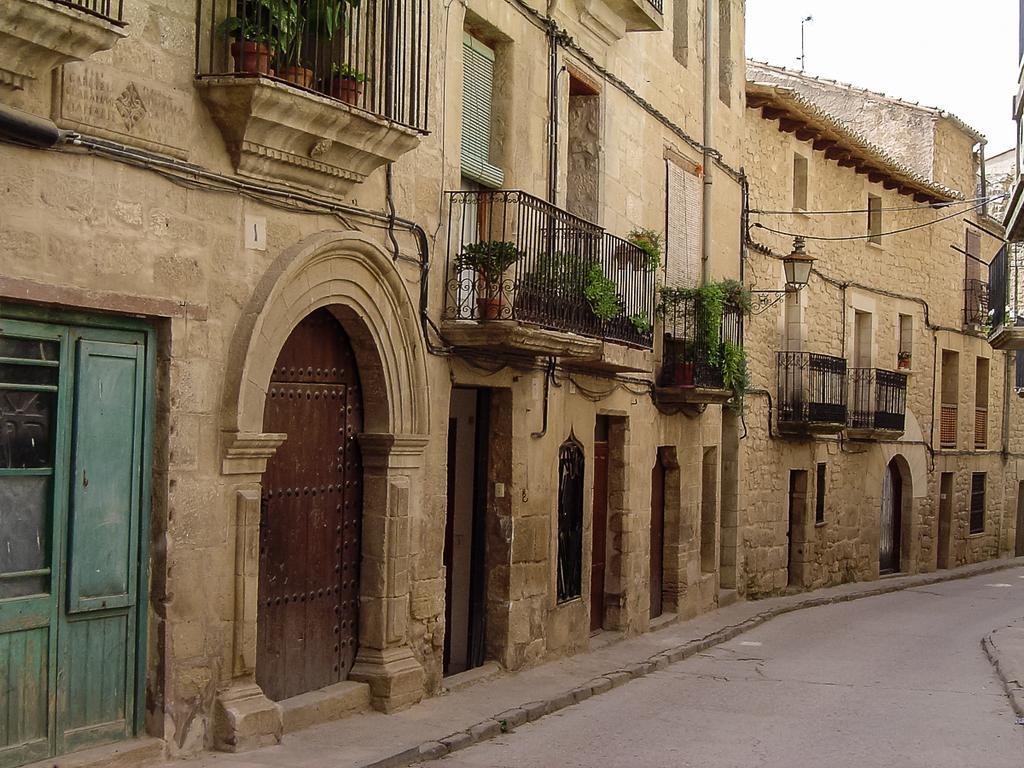Please provide a concise description of this image. In the center of the image we can see the sky, buildings, fences, pots with plants, doors, road and a few objects. 